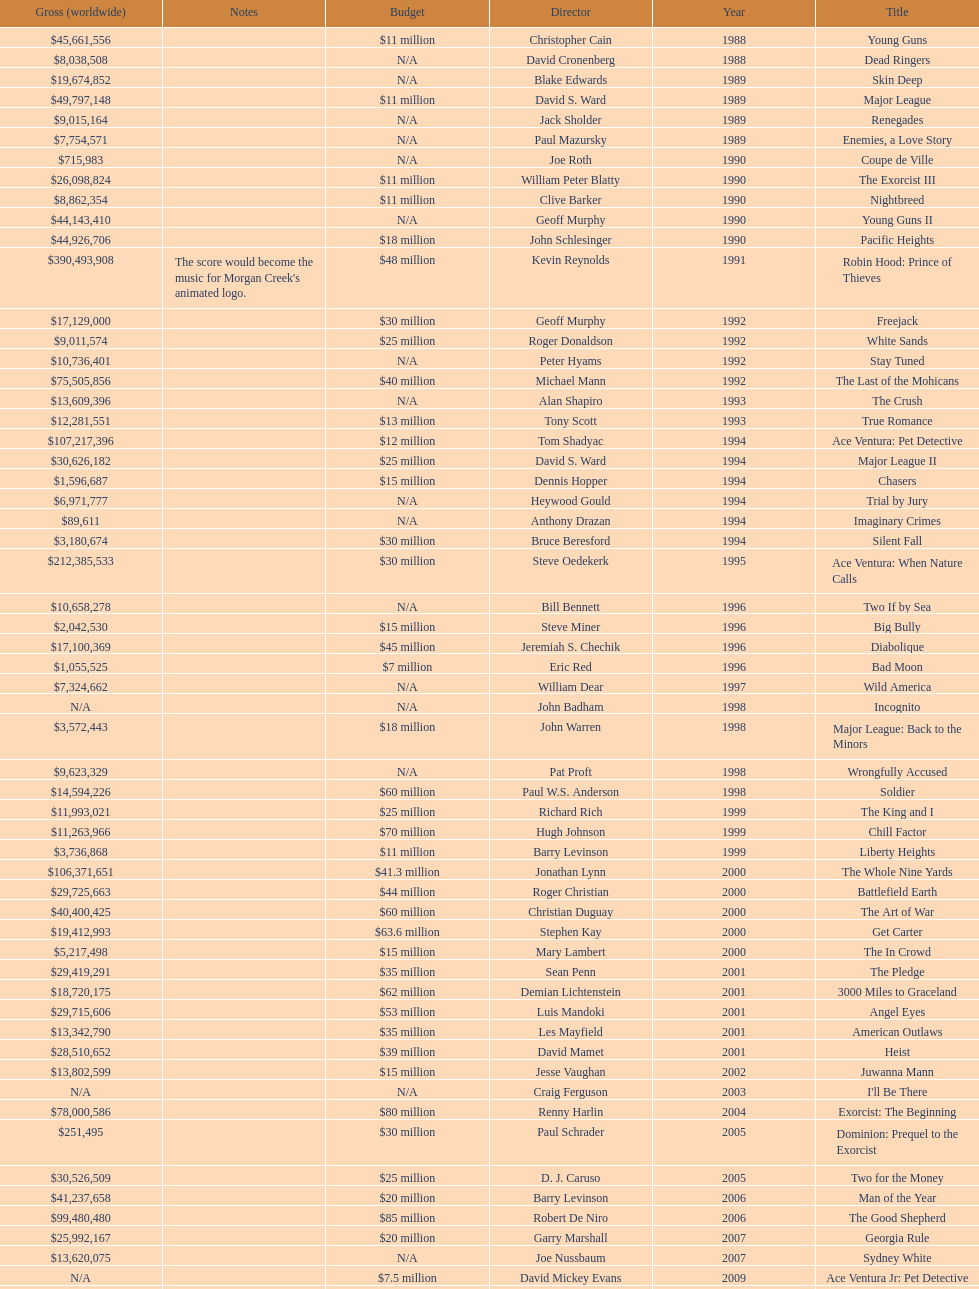Was the budget for young guns more or less than freejack's budget? Less. 